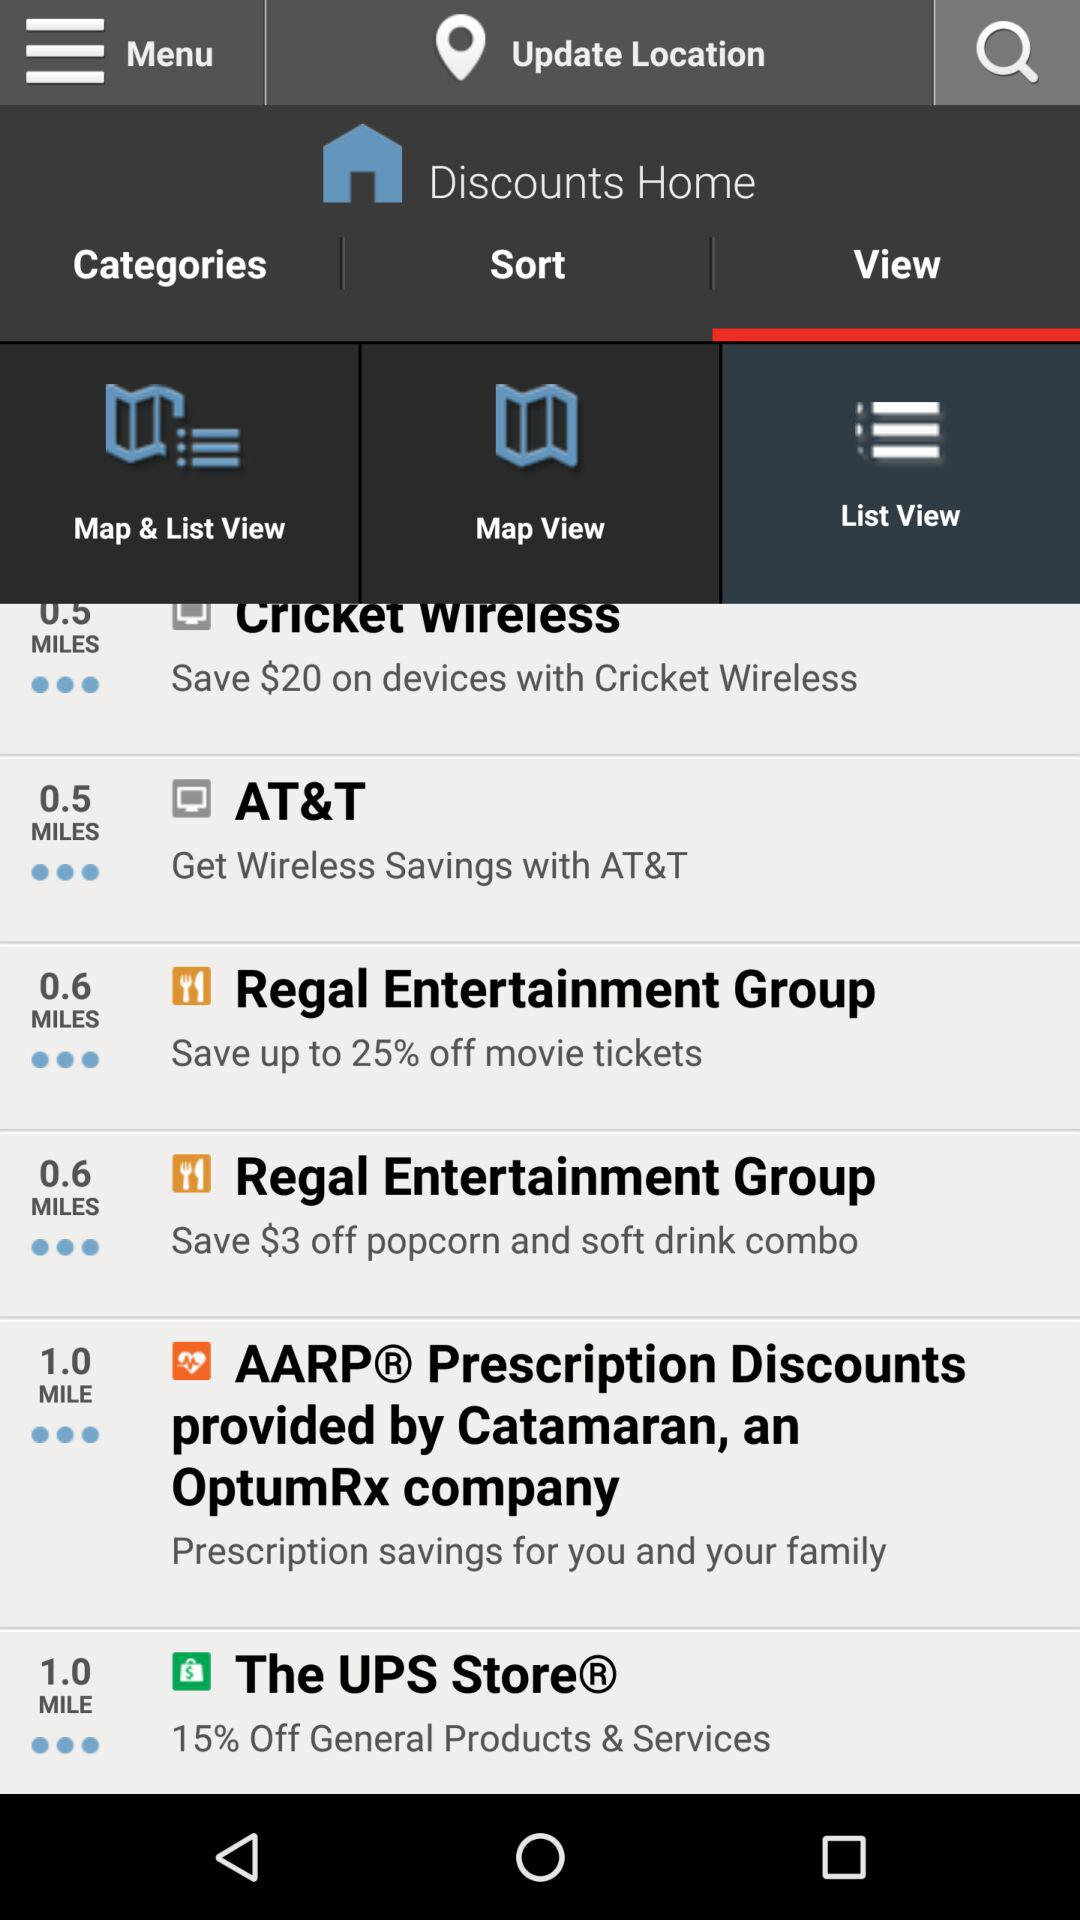How much can we save on movie tickets? You can save up to 25% on movie tickets. 